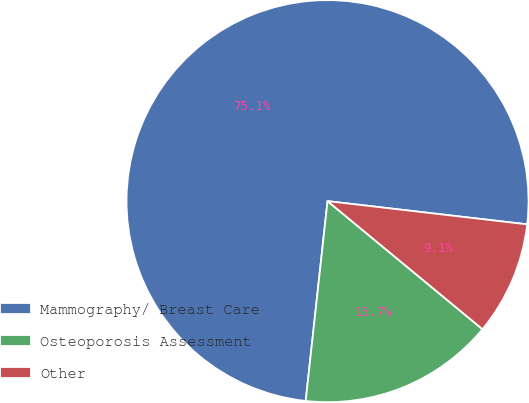Convert chart. <chart><loc_0><loc_0><loc_500><loc_500><pie_chart><fcel>Mammography/ Breast Care<fcel>Osteoporosis Assessment<fcel>Other<nl><fcel>75.11%<fcel>15.74%<fcel>9.15%<nl></chart> 